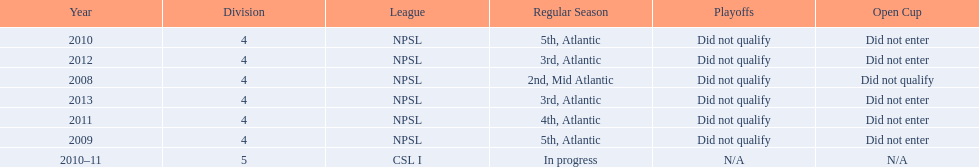What are the names of the leagues? NPSL, CSL I. Which league other than npsl did ny soccer team play under? CSL I. 